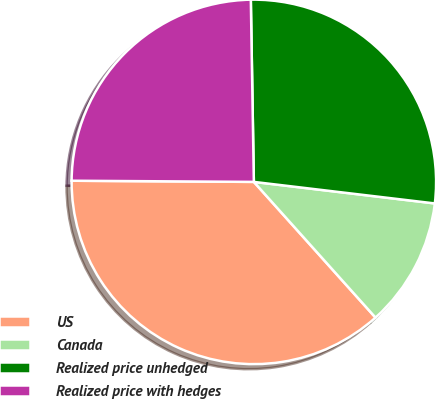<chart> <loc_0><loc_0><loc_500><loc_500><pie_chart><fcel>US<fcel>Canada<fcel>Realized price unhedged<fcel>Realized price with hedges<nl><fcel>36.73%<fcel>11.48%<fcel>27.15%<fcel>24.63%<nl></chart> 